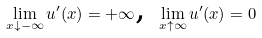Convert formula to latex. <formula><loc_0><loc_0><loc_500><loc_500>\lim _ { x \downarrow - \infty } u ^ { \prime } ( x ) = + \infty \text {, } \lim _ { x \uparrow \infty } u ^ { \prime } ( x ) = 0</formula> 